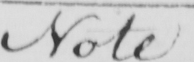What is written in this line of handwriting? Note 